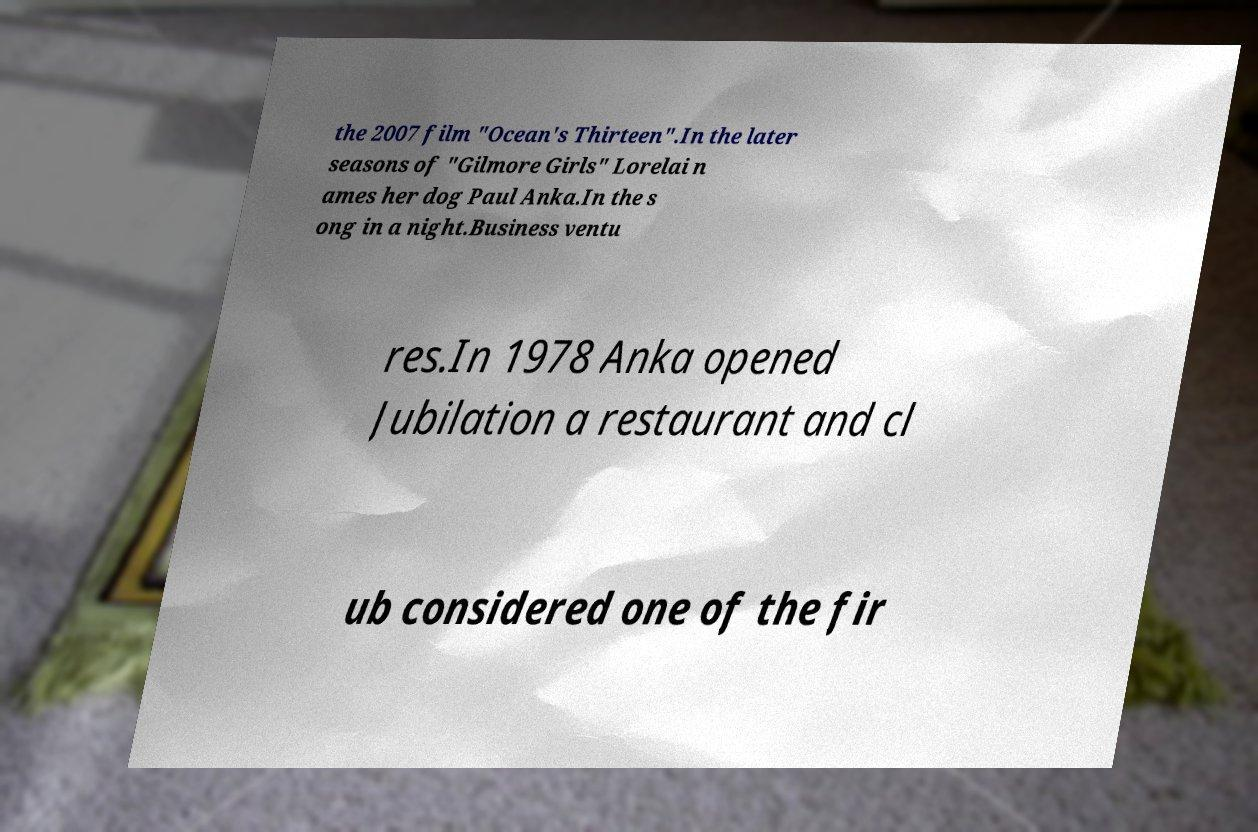Could you assist in decoding the text presented in this image and type it out clearly? the 2007 film "Ocean's Thirteen".In the later seasons of "Gilmore Girls" Lorelai n ames her dog Paul Anka.In the s ong in a night.Business ventu res.In 1978 Anka opened Jubilation a restaurant and cl ub considered one of the fir 